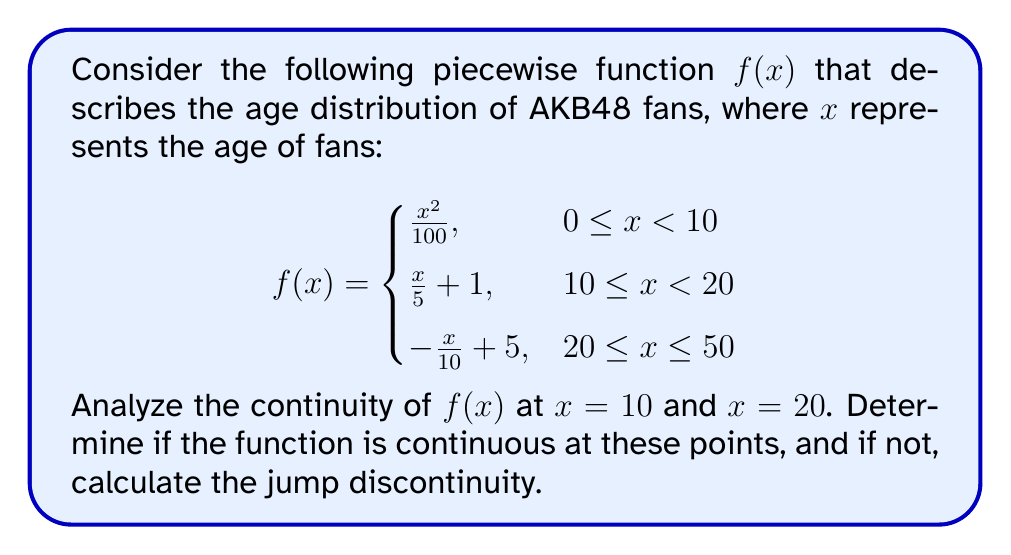Solve this math problem. To analyze the continuity of the piecewise function $f(x)$ at $x = 10$ and $x = 20$, we need to check three conditions at each point:

1. The function is defined at the point.
2. The limit of the function exists as we approach the point from both sides.
3. The limit equals the function value at that point.

Let's start with $x = 10$:

1. $f(10)$ is defined: $f(10) = \frac{10}{5} + 1 = 3$

2. Left-hand limit:
   $\lim_{x \to 10^-} f(x) = \lim_{x \to 10^-} \frac{x^2}{100} = \frac{10^2}{100} = 1$

   Right-hand limit:
   $\lim_{x \to 10^+} f(x) = \lim_{x \to 10^+} (\frac{x}{5} + 1) = \frac{10}{5} + 1 = 3$

3. The left-hand limit (1) does not equal the right-hand limit (3), so $f(x)$ is not continuous at $x = 10$.

The jump discontinuity at $x = 10$ is:
$3 - 1 = 2$

Now, let's check $x = 20$:

1. $f(20)$ is defined: $f(20) = -\frac{20}{10} + 5 = 3$

2. Left-hand limit:
   $\lim_{x \to 20^-} f(x) = \lim_{x \to 20^-} (\frac{x}{5} + 1) = \frac{20}{5} + 1 = 5$

   Right-hand limit:
   $\lim_{x \to 20^+} f(x) = \lim_{x \to 20^+} (-\frac{x}{10} + 5) = -\frac{20}{10} + 5 = 3$

3. The left-hand limit (5) does not equal the right-hand limit (3), so $f(x)$ is not continuous at $x = 20$.

The jump discontinuity at $x = 20$ is:
$5 - 3 = 2$
Answer: The function $f(x)$ is not continuous at $x = 10$ or $x = 20$. There is a jump discontinuity of 2 at both $x = 10$ and $x = 20$. 